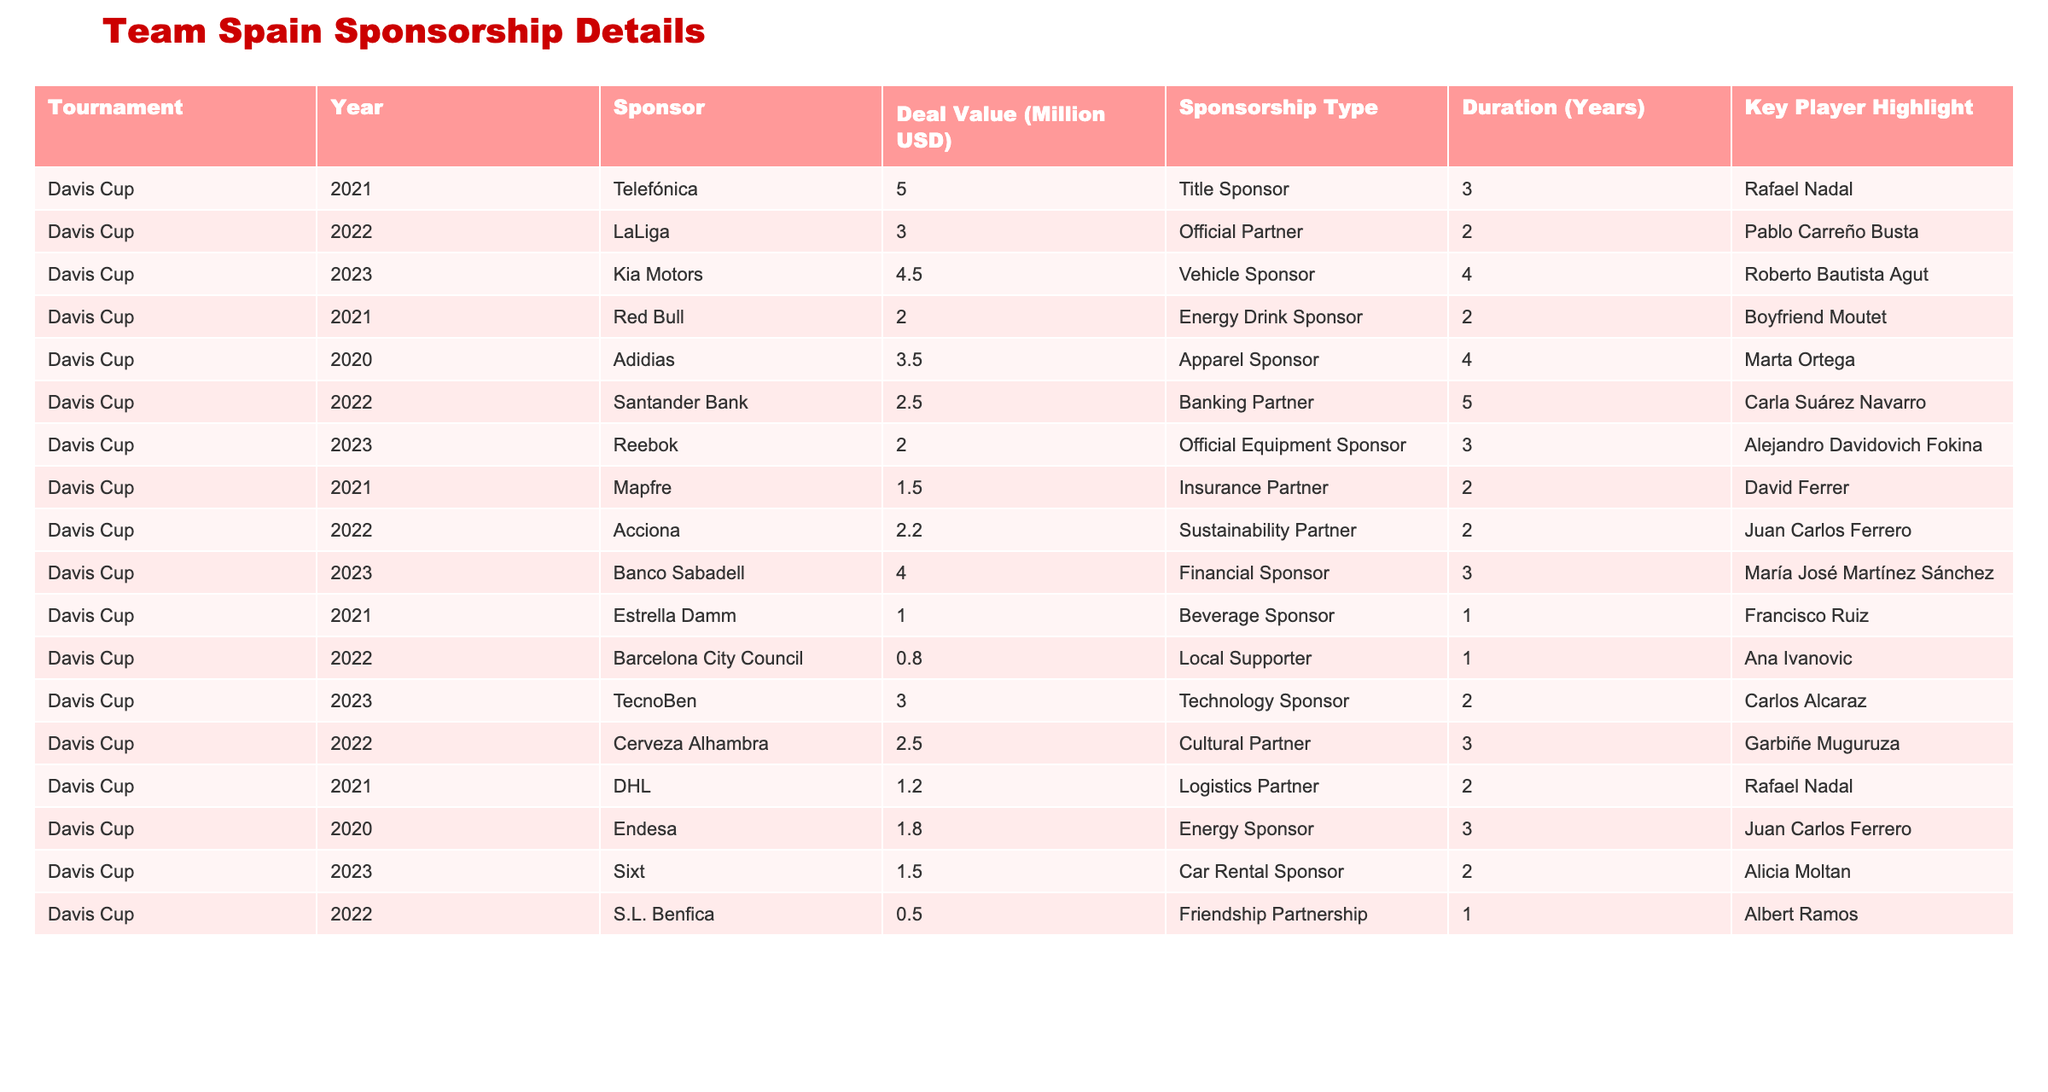What is the total sponsorship deal value for Team Spain in 2023? By examining the 2023 row from the table, the deal values are 4.5, 2.0, 4.0, and 1.5 million USD from different sponsors. Adding them together: 4.5 + 2.0 + 4.0 + 1.5 = 12.0 million USD.
Answer: 12.0 million USD Who is the key player highlighted for the sponsorship deal with Kia Motors in 2023? The table indicates that the main player associated with Kia Motors in 2023 is Roberto Bautista Agut.
Answer: Roberto Bautista Agut Is the duration of the sponsorship deal with Banco Sabadell in 2023 more than 2 years? The duration listed in the table for Banco Sabadell is 3 years, which is indeed more than 2 years.
Answer: Yes What is the average deal value for all sponsors from 2021 to 2023? The deal values from 2021 to 2023 are: 5.0, 3.0, 4.5, 2.0, 3.5, 2.5, 4.0, 1.5, 2.0, 0.8, 2.5, 1.2, 1.8, 1.5, 3.0, 0.5; summing all gives 34.5 million USD. There are 16 entries, so the average is 34.5 / 16 = 2.15625.
Answer: 2.16 million USD Which sponsor had the least deal value in 2022 and what was it? Looking at 2022 sponsorships, the smallest deal is with S.L. Benfica at 0.5 million USD.
Answer: S.L. Benfica, 0.5 million USD How many sponsors have a deal value greater than 2.0 million USD in 2021? The sponsors with deal values greater than 2.0 million USD in 2021 are Telefónica (5.0), Red Bull (2.0), and Adidas (3.5) making a total of 3 sponsors.
Answer: 3 sponsors In which year did Team Spain receive the highest single deal value, and what was that value? The highest single deal value was 5.0 million USD in 2021 from Telefónica.
Answer: 2021, 5.0 million USD Which sponsorship category had the maximum duration across the data? The longest duration noted in the table is 5 years, corresponding to the sponsorship category with Santander Bank.
Answer: 5 years What is the total value of sponsorship deals associated with key player Rafael Nadal? The deals linked to Rafael Nadal are from Telefónica (5.0 million), and DHL (1.2 million), totaling 6.2 million USD.
Answer: 6.2 million USD Has any sponsorship category in 2020 had a deal value that surpassed 3 million USD? According to the table, the highest deal value in 2020 is 3.5 million USD with Adidas, so one sponsorship category did exceed 3 million USD.
Answer: Yes 